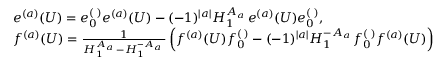<formula> <loc_0><loc_0><loc_500><loc_500>\begin{array} { r l } & { e ^ { ( a ) } ( U ) = e _ { 0 } ^ { ( \digamma ) } e ^ { ( a ) } ( U ) - ( - 1 ) ^ { | a | } H _ { 1 } ^ { A _ { a \digamma } } e ^ { ( a ) } ( U ) e _ { 0 } ^ { ( \digamma ) } , } \\ & { f ^ { ( a ) } ( U ) = \frac { 1 } { H _ { 1 } ^ { A _ { a \digamma } } - H _ { 1 } ^ { - A _ { a \digamma } } } \left ( f ^ { ( a ) } ( U ) f _ { 0 } ^ { ( \digamma ) } - ( - 1 ) ^ { | a | } H _ { 1 } ^ { - A _ { a \digamma } } f _ { 0 } ^ { ( \digamma ) } f ^ { ( a ) } ( U ) \right ) } \end{array}</formula> 